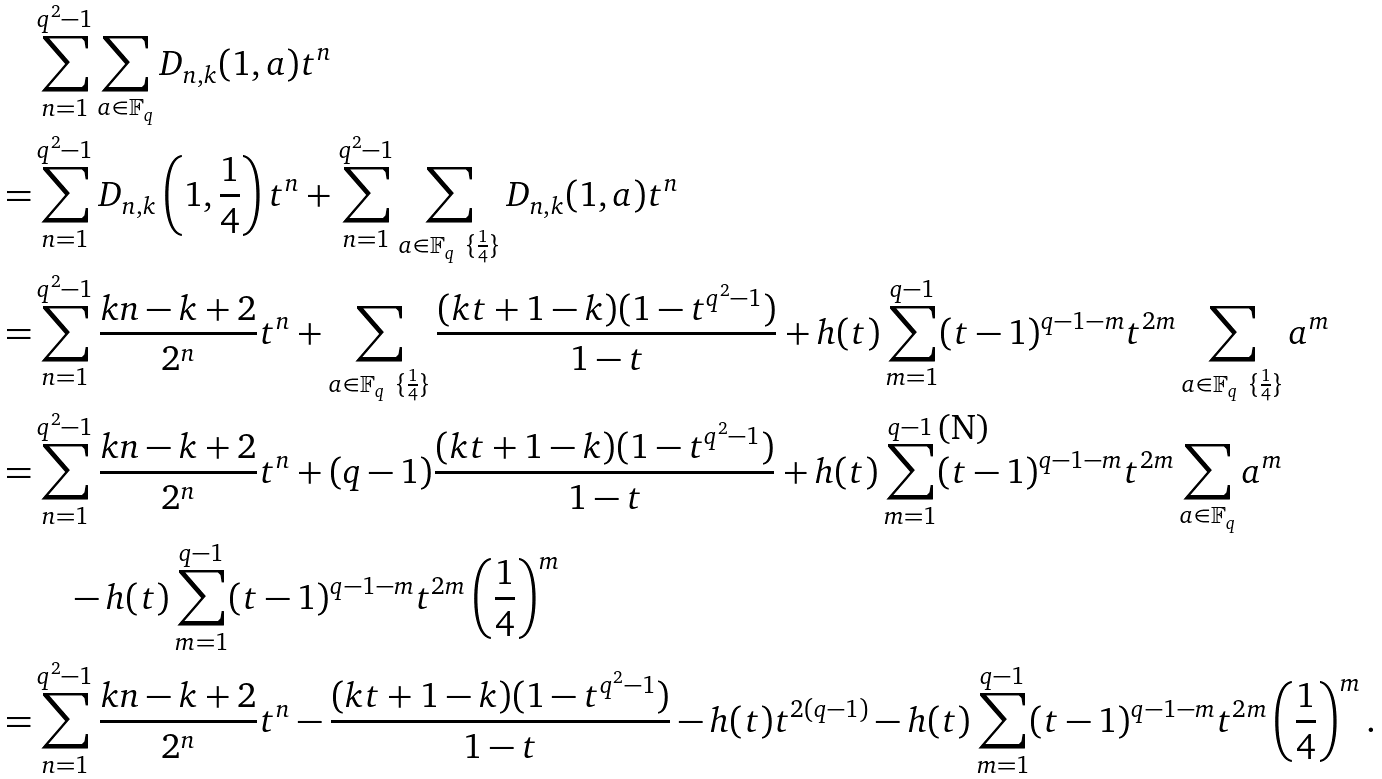<formula> <loc_0><loc_0><loc_500><loc_500>& \sum _ { n = 1 } ^ { q ^ { 2 } - 1 } \sum _ { a \in { \mathbb { F } _ { q } } } D _ { n , k } ( 1 , a ) t ^ { n } \\ = & \sum _ { n = 1 } ^ { q ^ { 2 } - 1 } D _ { n , k } \left ( 1 , \frac { 1 } { 4 } \right ) t ^ { n } + \sum _ { n = 1 } ^ { q ^ { 2 } - 1 } \sum _ { a \in { \mathbb { F } _ { q } } \ \{ \frac { 1 } { 4 } \} } D _ { n , k } ( 1 , a ) t ^ { n } \\ = & \sum _ { n = 1 } ^ { q ^ { 2 } - 1 } \frac { k n - k + 2 } { 2 ^ { n } } t ^ { n } + \sum _ { a \in { \mathbb { F } _ { q } } \ \{ \frac { 1 } { 4 } \} } \frac { ( k t + 1 - k ) ( 1 - t ^ { q ^ { 2 } - 1 } ) } { 1 - t } + h ( t ) \sum _ { m = 1 } ^ { q - 1 } ( t - 1 ) ^ { q - 1 - m } t ^ { 2 m } \sum _ { a \in { \mathbb { F } _ { q } } \ \{ \frac { 1 } { 4 } \} } a ^ { m } \\ = & \sum _ { n = 1 } ^ { q ^ { 2 } - 1 } \frac { k n - k + 2 } { 2 ^ { n } } t ^ { n } + ( q - 1 ) \frac { ( k t + 1 - k ) ( 1 - t ^ { q ^ { 2 } - 1 } ) } { 1 - t } + h ( t ) \sum _ { m = 1 } ^ { q - 1 } ( t - 1 ) ^ { q - 1 - m } t ^ { 2 m } \sum _ { a \in { \mathbb { F } _ { q } } } a ^ { m } \\ & \quad - h ( t ) \sum _ { m = 1 } ^ { q - 1 } ( t - 1 ) ^ { q - 1 - m } t ^ { 2 m } \left ( \frac { 1 } { 4 } \right ) ^ { m } \\ = & \sum _ { n = 1 } ^ { q ^ { 2 } - 1 } \frac { k n - k + 2 } { 2 ^ { n } } t ^ { n } - \frac { ( k t + 1 - k ) ( 1 - t ^ { q ^ { 2 } - 1 } ) } { 1 - t } - h ( t ) t ^ { 2 ( q - 1 ) } - h ( t ) \sum _ { m = 1 } ^ { q - 1 } ( t - 1 ) ^ { q - 1 - m } t ^ { 2 m } \left ( \frac { 1 } { 4 } \right ) ^ { m } .</formula> 